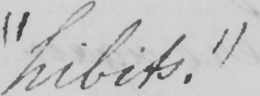Please transcribe the handwritten text in this image. " hibits . 